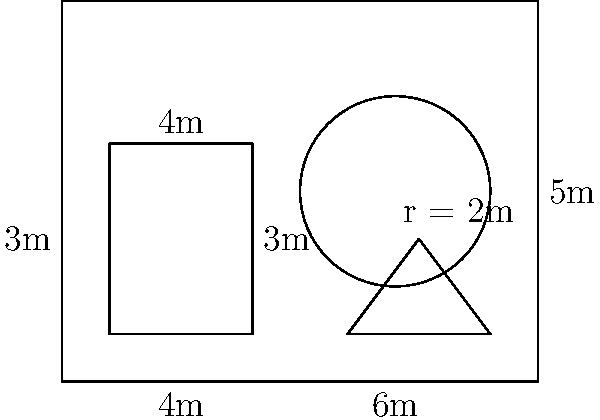You're planning a massive graffiti mural on a wall that measures 10m wide and 8m high. Within this wall, you want to create three distinct sections: a rectangular area for your crew's tag, a circular design for your logo, and a triangular space for a special message. The rectangular section measures 3m by 4m, the circular logo has a radius of 2m, and the triangular section has a base of 3m and a height of 2m. What's the total area, in square meters, that will remain unpainted on the wall? Let's break this down step-by-step:

1. Calculate the total area of the wall:
   $A_{wall} = 10m \times 8m = 80m^2$

2. Calculate the area of the rectangular section:
   $A_{rectangle} = 3m \times 4m = 12m^2$

3. Calculate the area of the circular logo:
   $A_{circle} = \pi r^2 = \pi \times (2m)^2 = 4\pi m^2$

4. Calculate the area of the triangular section:
   $A_{triangle} = \frac{1}{2} \times base \times height = \frac{1}{2} \times 3m \times 2m = 3m^2$

5. Sum up the areas of all painted sections:
   $A_{painted} = A_{rectangle} + A_{circle} + A_{triangle}$
   $A_{painted} = 12m^2 + 4\pi m^2 + 3m^2 = (15 + 4\pi) m^2$

6. Calculate the unpainted area by subtracting the painted area from the total wall area:
   $A_{unpainted} = A_{wall} - A_{painted}$
   $A_{unpainted} = 80m^2 - (15 + 4\pi) m^2$
   $A_{unpainted} = (65 - 4\pi) m^2$

Therefore, the area that will remain unpainted is $(65 - 4\pi)$ square meters.
Answer: $(65 - 4\pi)m^2$ 